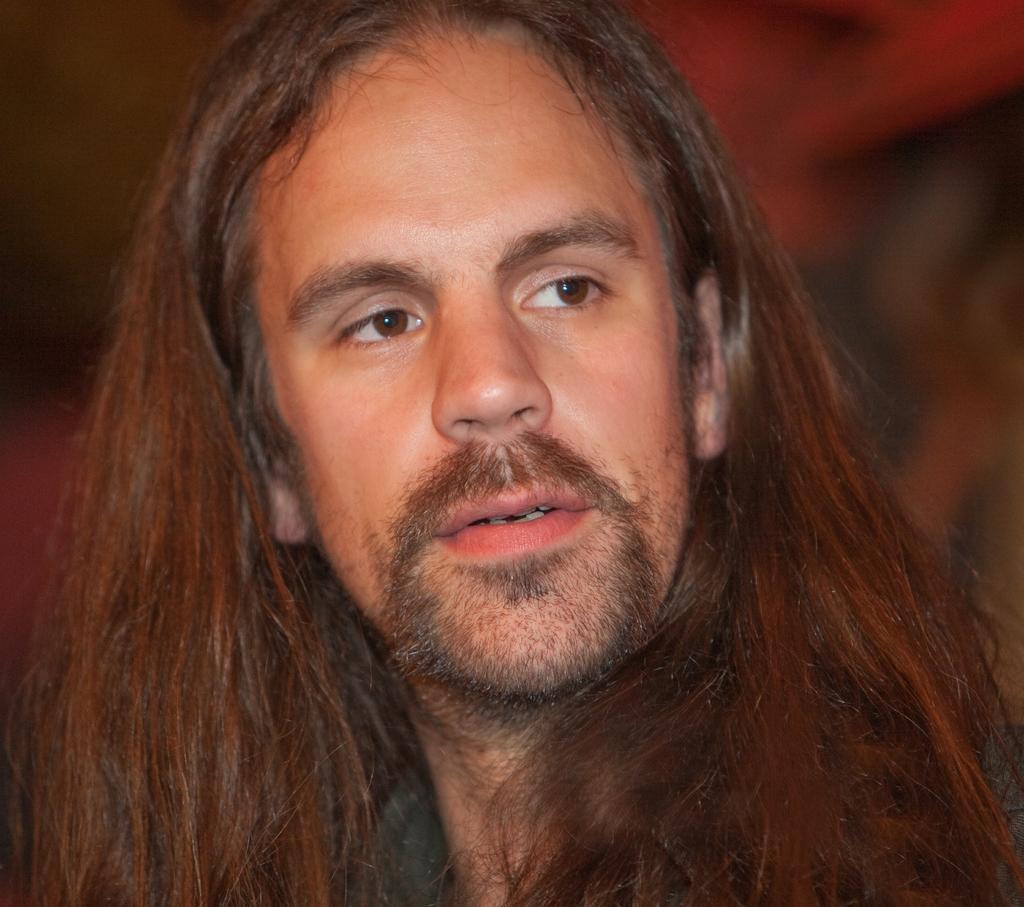Could you give a brief overview of what you see in this image? This picture shows a man with long hair 